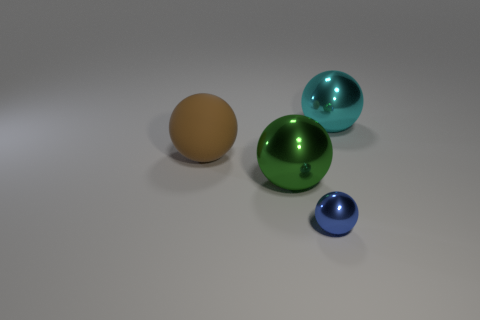Is the material of the cyan thing the same as the big sphere that is in front of the big brown matte thing?
Offer a very short reply. Yes. What number of objects are metal things on the left side of the big cyan shiny ball or metal spheres?
Provide a short and direct response. 3. Is the shape of the large rubber thing the same as the thing in front of the big green sphere?
Your answer should be very brief. Yes. What number of large shiny objects are both behind the brown matte sphere and on the left side of the blue sphere?
Offer a very short reply. 0. What material is the cyan thing that is the same shape as the large brown thing?
Your answer should be very brief. Metal. There is a thing that is in front of the large metal sphere left of the big cyan metal ball; how big is it?
Give a very brief answer. Small. Are there any large green metal objects?
Your answer should be very brief. Yes. What material is the large object that is on the left side of the big cyan object and on the right side of the brown rubber ball?
Your answer should be very brief. Metal. Are there more big green balls that are in front of the small blue sphere than large balls to the right of the large cyan metal object?
Offer a very short reply. No. Are there any green shiny objects of the same size as the cyan metal thing?
Give a very brief answer. Yes. 